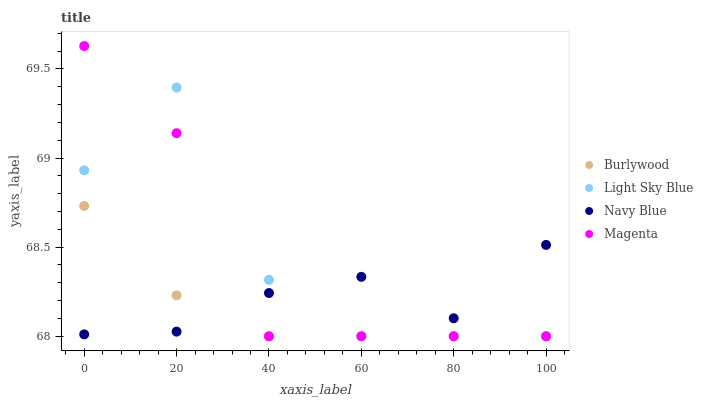Does Burlywood have the minimum area under the curve?
Answer yes or no. Yes. Does Light Sky Blue have the maximum area under the curve?
Answer yes or no. Yes. Does Navy Blue have the minimum area under the curve?
Answer yes or no. No. Does Navy Blue have the maximum area under the curve?
Answer yes or no. No. Is Burlywood the smoothest?
Answer yes or no. Yes. Is Light Sky Blue the roughest?
Answer yes or no. Yes. Is Navy Blue the smoothest?
Answer yes or no. No. Is Navy Blue the roughest?
Answer yes or no. No. Does Burlywood have the lowest value?
Answer yes or no. Yes. Does Navy Blue have the lowest value?
Answer yes or no. No. Does Magenta have the highest value?
Answer yes or no. Yes. Does Navy Blue have the highest value?
Answer yes or no. No. Does Burlywood intersect Magenta?
Answer yes or no. Yes. Is Burlywood less than Magenta?
Answer yes or no. No. Is Burlywood greater than Magenta?
Answer yes or no. No. 